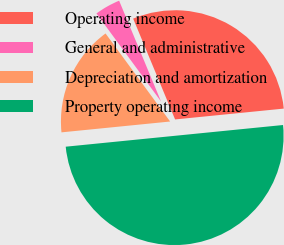Convert chart. <chart><loc_0><loc_0><loc_500><loc_500><pie_chart><fcel>Operating income<fcel>General and administrative<fcel>Depreciation and amortization<fcel>Property operating income<nl><fcel>29.69%<fcel>3.8%<fcel>16.51%<fcel>50.0%<nl></chart> 